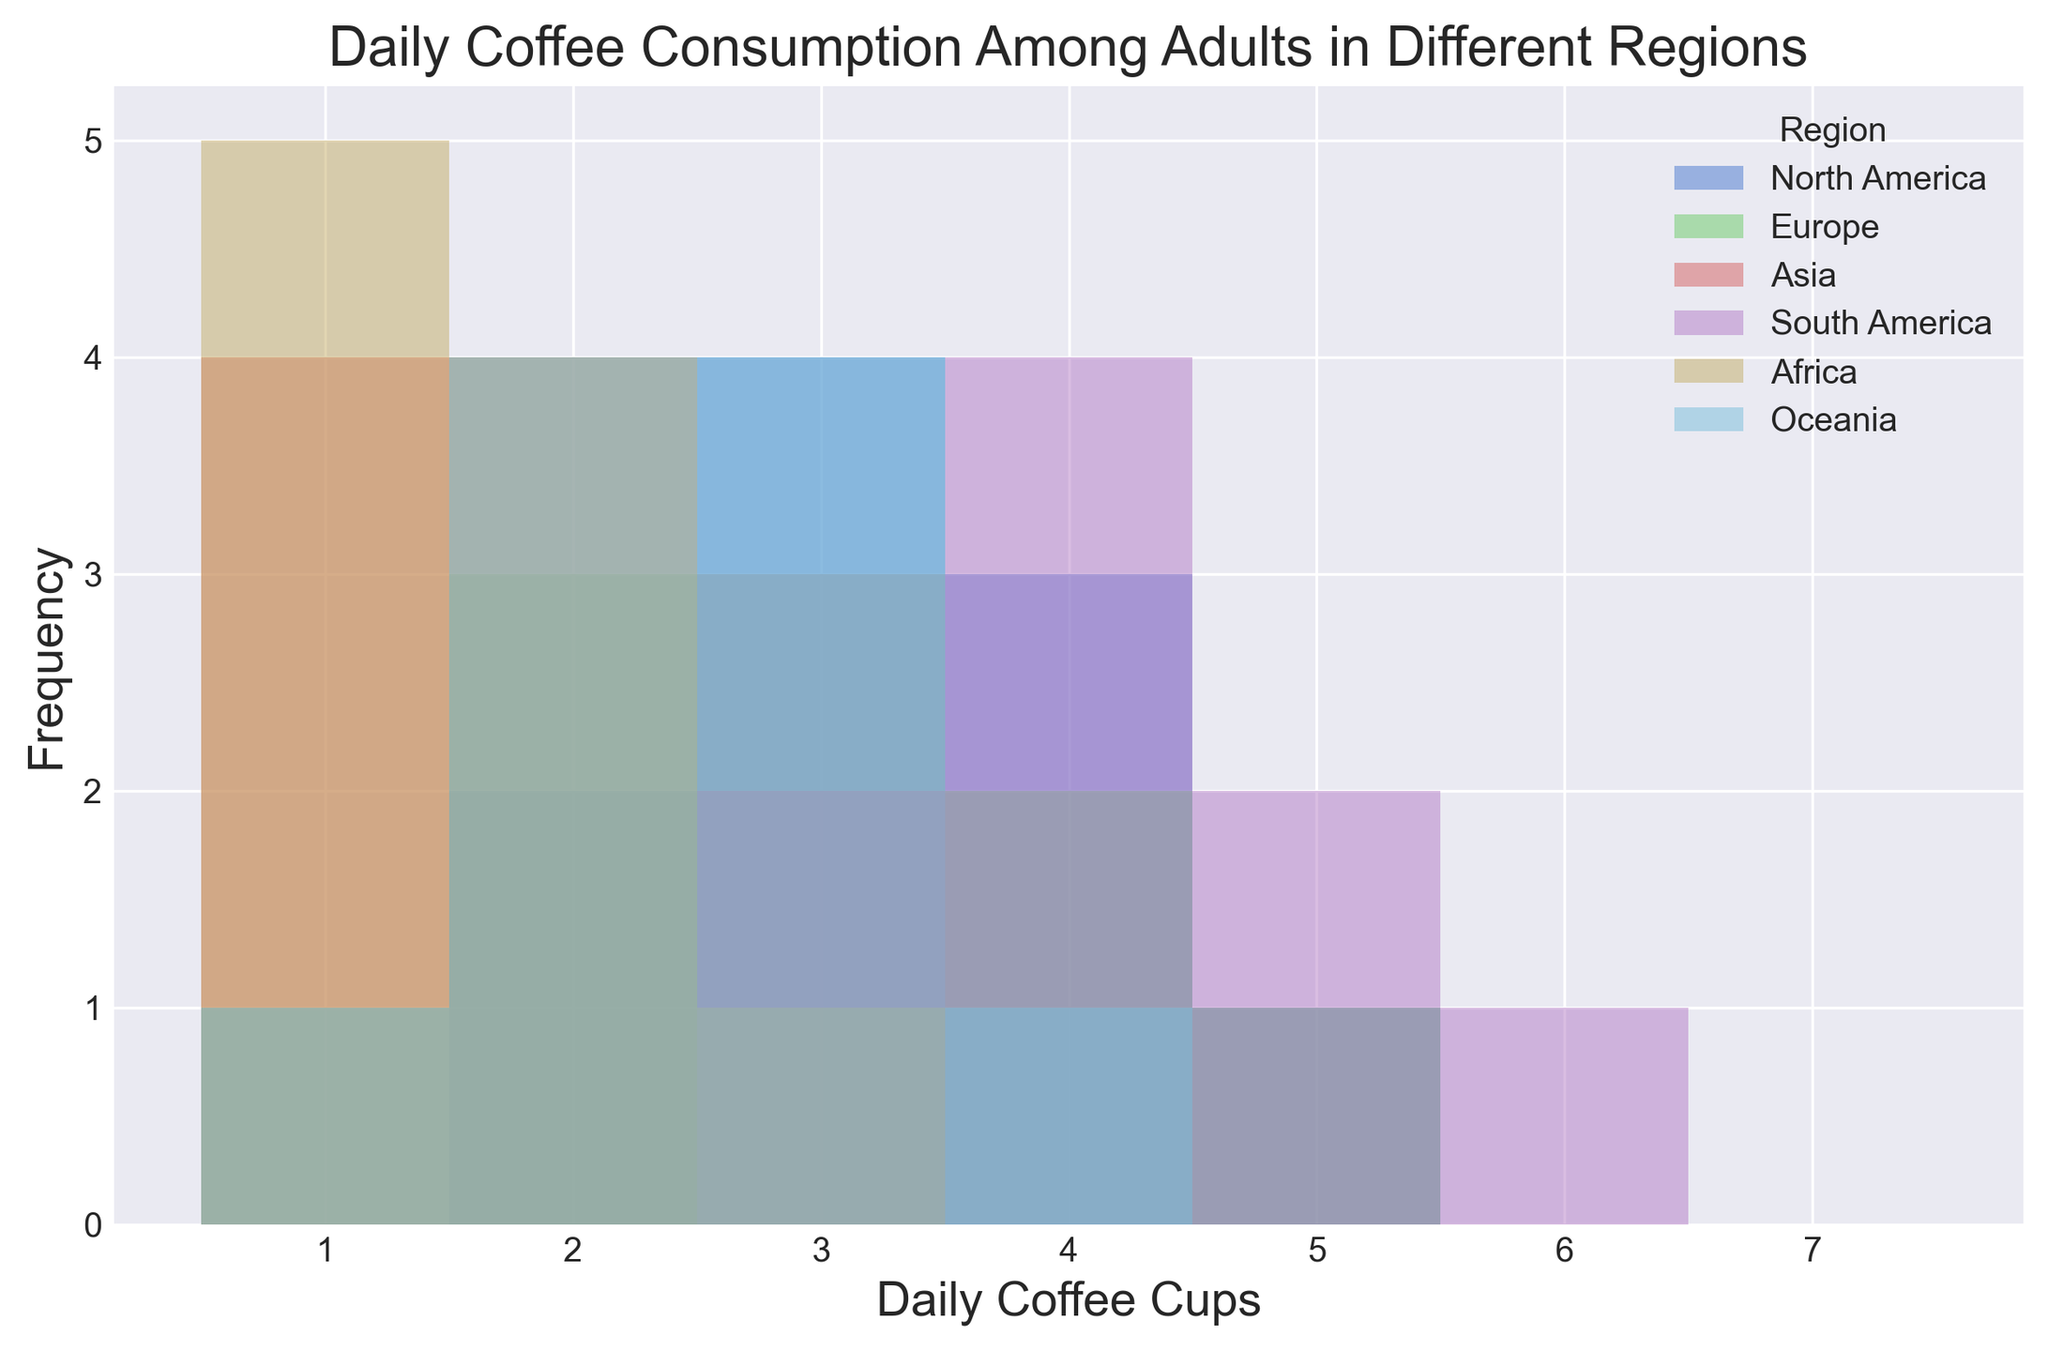Which region has the highest frequency of consuming 1 cup of coffee per day? The figure shows the frequency of each region's daily coffee consumption. Looking at the bars representing the number of 1-cup coffee drinkers, Africa has the highest bar compared to other regions.
Answer: Africa Which region has the most diverse range of daily coffee consumption? The range is evaluated by the spread of values on the x-axis for each region. North America and Europe show a range from 1 to 5 cups, while Africa has a narrower range, primarily 1 to 3 cups. Asia also ranges from 1 to 3 cups, and South America spans 3 to 6 cups. Therefore, North America and Europe show the widest range, indicating the most diversity.
Answer: North America and Europe Which region has the highest average daily coffee consumption? To find the highest average, we consider the position and frequency of the bars for each region. North America's bars are clustered around 3-4 cups, South America's bars are slightly higher around 3-5 cups. Comparing average bar heights and centroids visually, South America appears to have the highest average.
Answer: South America How many regions have their most frequent coffee consumption at 2 cups per day? By looking at the figure, identify the bars that peak at the value of 2 cups across different regions. Both Asia and Africa show their highest bars at the 2-cup mark.
Answer: Two Which region shows a peak coffee consumption of 5 cups per day? Check the histogram for the regions whose bar heights peak at the 5-cup mark. South America and North America have visible peaks at 5 cups per day.
Answer: South America and North America For Europe, what is the difference in frequency between those consuming 3 cups and those consuming 4 cups of coffee daily? Identify the height of the bars for Europe at 3 cups and 4 cups, then subtract the frequency of the 4-cup bar from the 3-cup bar. The bars for 3 cups and 4 cups are almost the same, indicating no significant difference.
Answer: 0 Is there any region where 1 cup of coffee per day is the least consumed amount? Analyze each region's histogram bars. North America, Europe, South America, Oceania, and Asia have minimal bars at 1 cup compared to other consumption levels.
Answer: No In North America, what is the combined frequency of people who drink 2 or 3 cups of coffee daily? Identify the bar heights for 2 and 3 cups in North America and add them. There are 2 bars for 2 cups (2, 3 pieces) and 2 for 3 cups (3, 4, 2, 4, 2). Summing these, the combined frequency is 3 + 4 + 2 + 4 + 2 = 15.
Answer: 15 